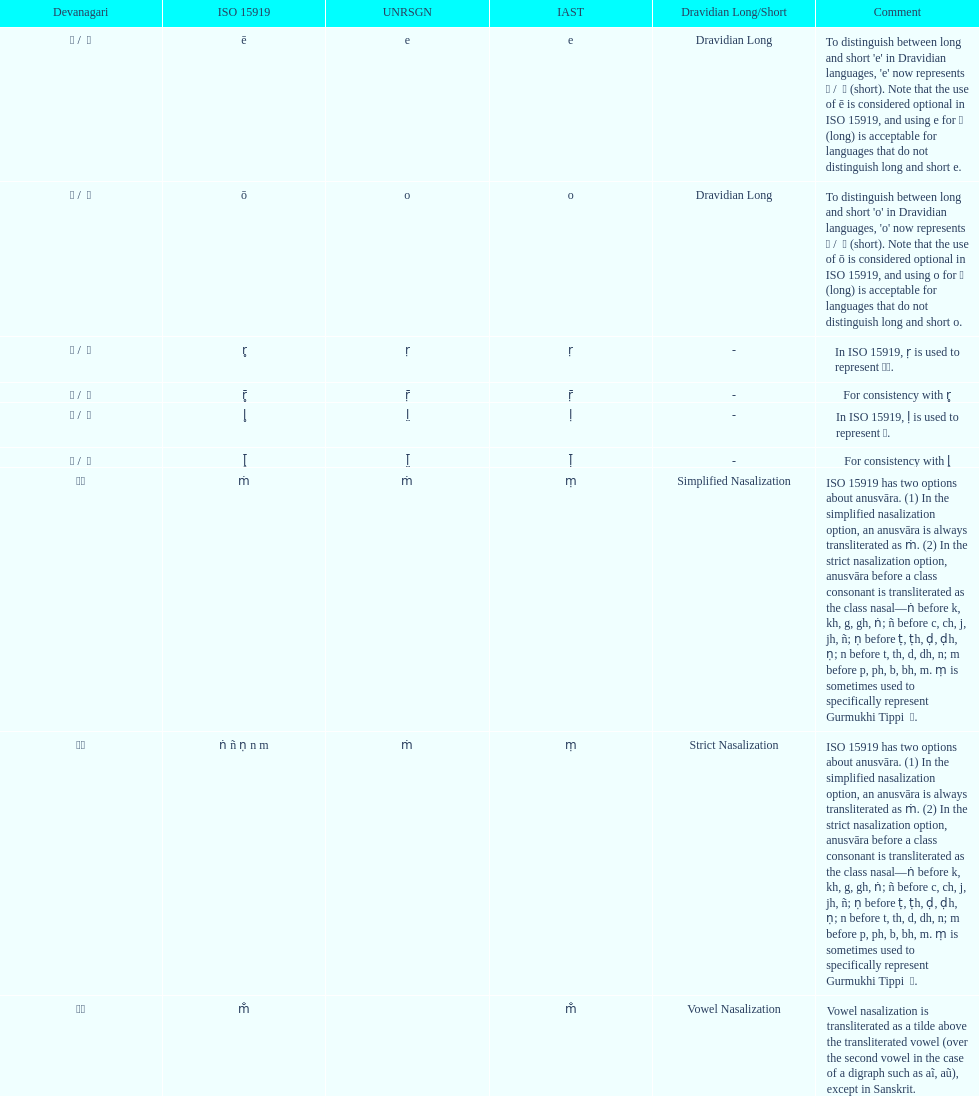Which devanagari character corresponds to the iast letter 'o'? ओ / ो. 